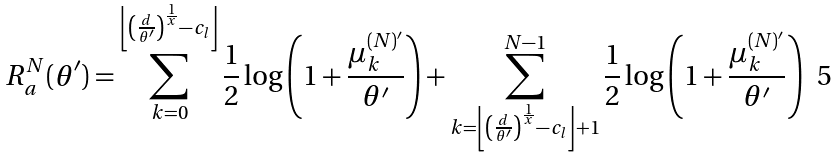Convert formula to latex. <formula><loc_0><loc_0><loc_500><loc_500>R _ { a } ^ { N } ( \theta ^ { \prime } ) & = \sum _ { k = 0 } ^ { \left \lfloor \left ( \frac { d } { \theta ^ { \prime } } \right ) ^ { \frac { 1 } { x } } - c _ { l } \right \rfloor } \frac { 1 } { 2 } \log \left ( 1 + \frac { \mu _ { k } ^ { ( N ) ^ { \prime } } } { \theta ^ { \prime } } \right ) + \sum ^ { N - 1 } _ { k = \left \lfloor \left ( \frac { d } { \theta ^ { \prime } } \right ) ^ { \frac { 1 } { x } } - c _ { l } \right \rfloor + 1 } \frac { 1 } { 2 } \log \left ( 1 + \frac { \mu _ { k } ^ { ( N ) ^ { \prime } } } { \theta ^ { \prime } } \right )</formula> 